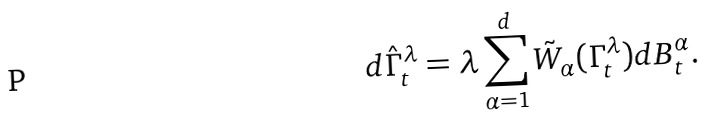Convert formula to latex. <formula><loc_0><loc_0><loc_500><loc_500>d \hat { \Gamma } ^ { \lambda } _ { t } = \lambda \sum _ { \alpha = 1 } ^ { d } \tilde { W } _ { \alpha } ( \Gamma ^ { \lambda } _ { t } ) d B ^ { \alpha } _ { t } .</formula> 